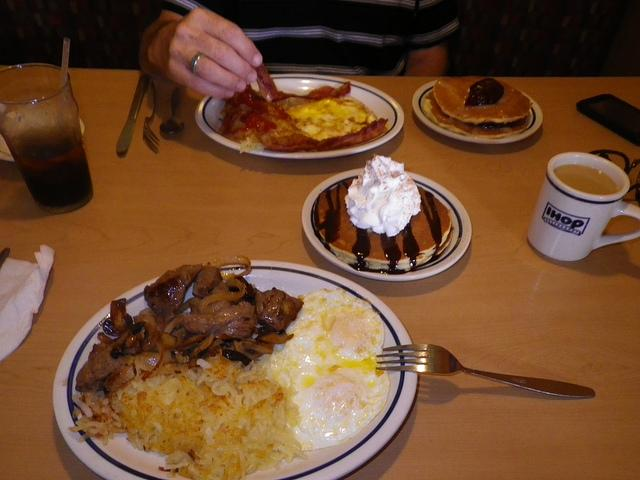What food on the table contains the highest amount of fat? bacon 